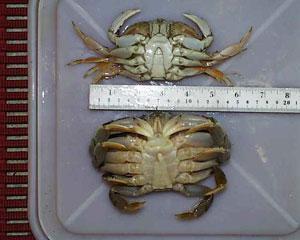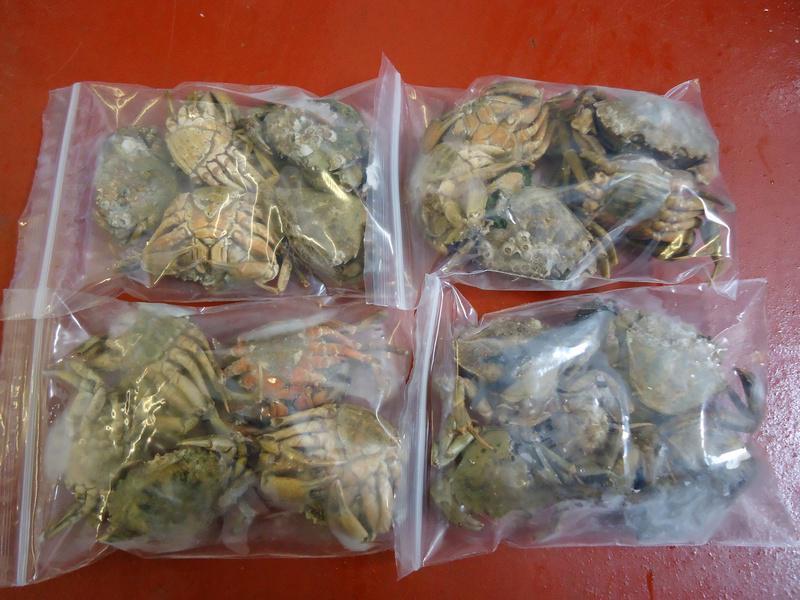The first image is the image on the left, the second image is the image on the right. Analyze the images presented: Is the assertion "The left image shows one clear plastic wrapper surrounding red-orange crab claws, and the right image shows multiple individually plastic wrapped crabs." valid? Answer yes or no. No. The first image is the image on the left, the second image is the image on the right. For the images displayed, is the sentence "A ruler depicts the size of a crab." factually correct? Answer yes or no. Yes. 